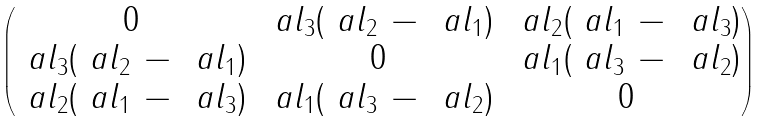Convert formula to latex. <formula><loc_0><loc_0><loc_500><loc_500>\begin{pmatrix} 0 & \ a l _ { 3 } ( \ a l _ { 2 } \, - \, \ a l _ { 1 } ) & \ a l _ { 2 } ( \ a l _ { 1 } \, - \, \ a l _ { 3 } ) \\ \ a l _ { 3 } ( \ a l _ { 2 } \, - \, \ a l _ { 1 } ) & 0 & \ a l _ { 1 } ( \ a l _ { 3 } \, - \, \ a l _ { 2 } ) \\ \ a l _ { 2 } ( \ a l _ { 1 } \, - \, \ a l _ { 3 } ) & \ a l _ { 1 } ( \ a l _ { 3 } \, - \, \ a l _ { 2 } ) & 0 \end{pmatrix}</formula> 